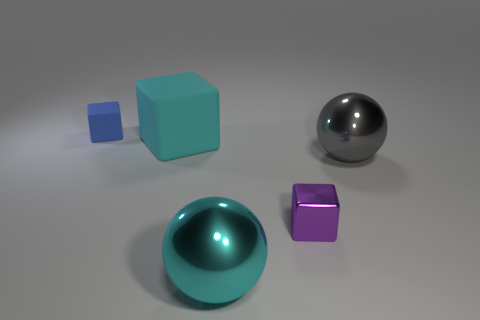Subtract all big rubber blocks. How many blocks are left? 2 Subtract 1 cubes. How many cubes are left? 2 Add 4 cyan shiny spheres. How many objects exist? 9 Subtract all spheres. How many objects are left? 3 Add 4 blue rubber blocks. How many blue rubber blocks are left? 5 Add 5 large purple spheres. How many large purple spheres exist? 5 Subtract 1 gray balls. How many objects are left? 4 Subtract all blue cubes. Subtract all cyan metal balls. How many objects are left? 3 